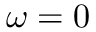<formula> <loc_0><loc_0><loc_500><loc_500>\omega = 0</formula> 